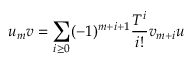<formula> <loc_0><loc_0><loc_500><loc_500>u _ { m } v = \sum _ { i \geq 0 } ( - 1 ) ^ { m + i + 1 } { \frac { T ^ { i } } { i ! } } v _ { m + i } u</formula> 